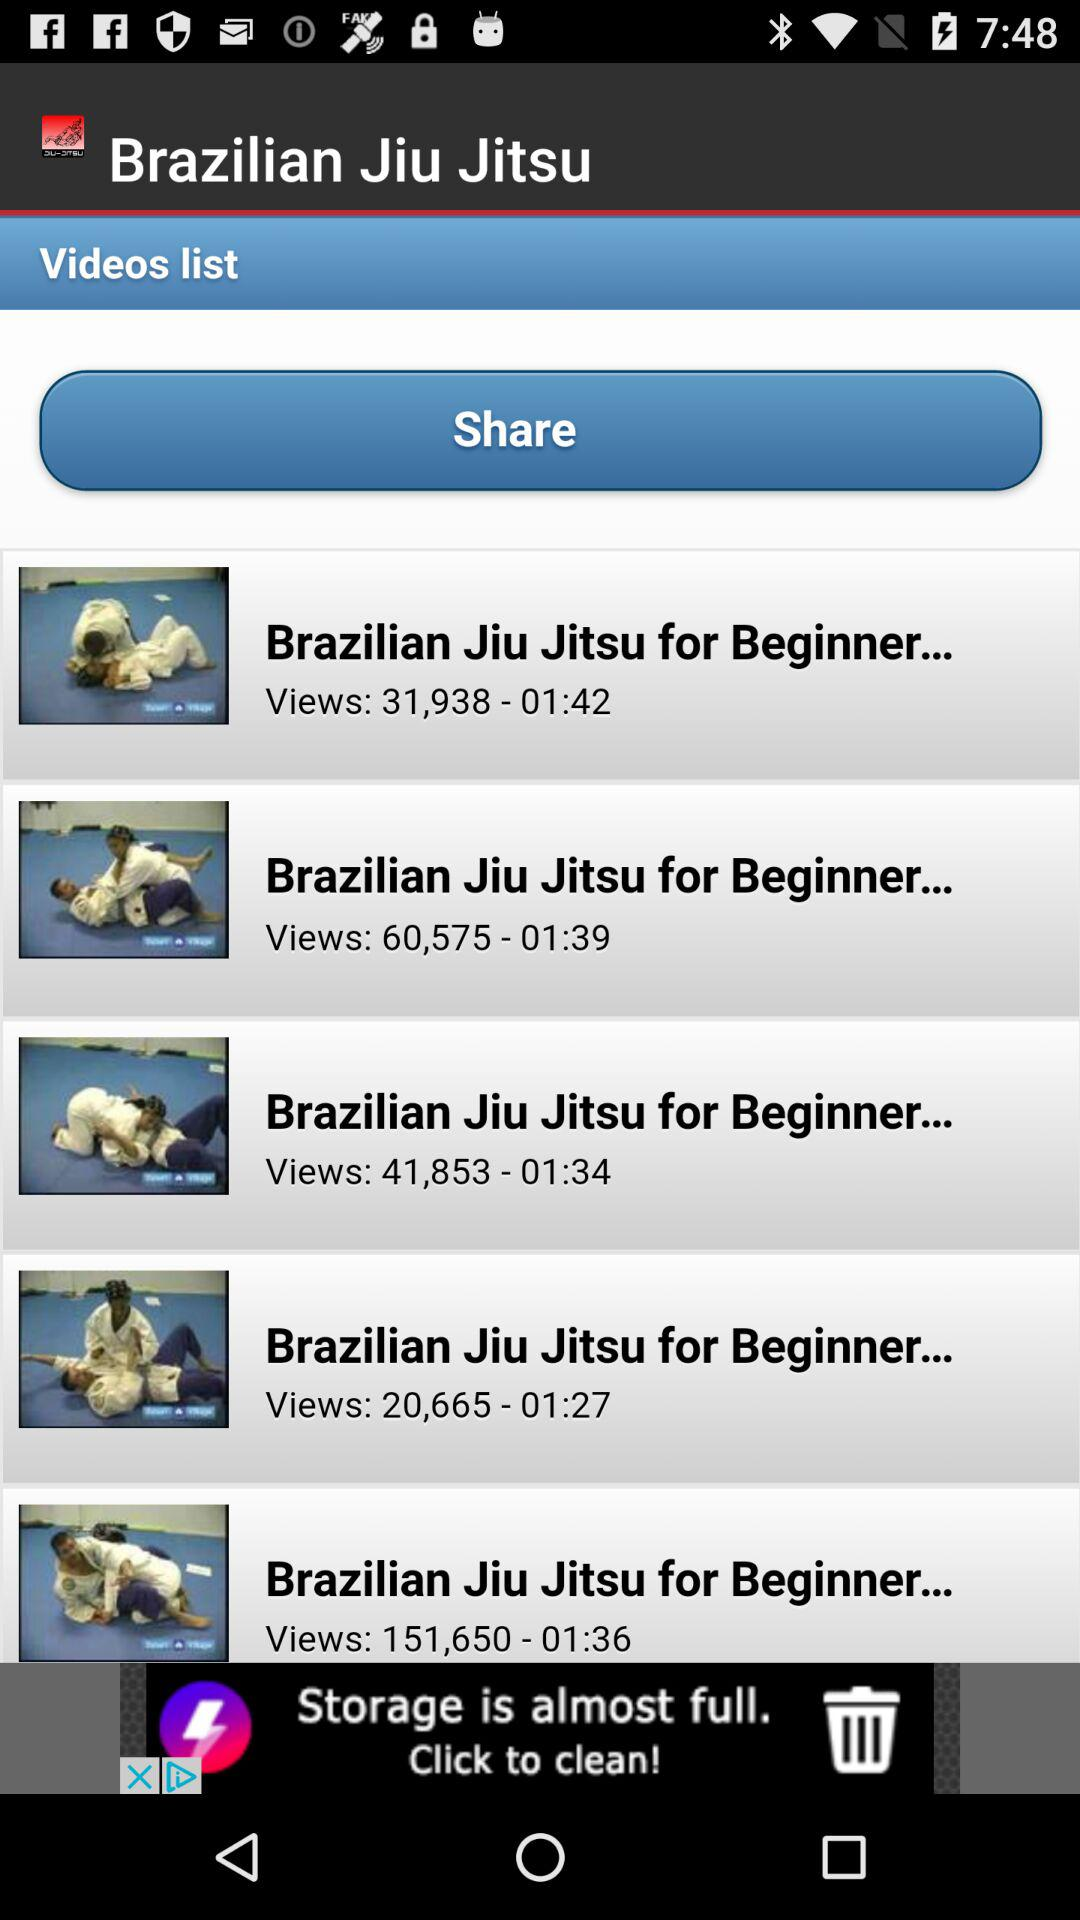What number of views are there of the "Brazilian Jiu Jitsu for Beginner..." video of time duration one minute thirty-four seconds? There are 41,853 views of the "Brazilian Jiu Jitsu for Beginner..." video of time duration one minute thirty-four seconds. 